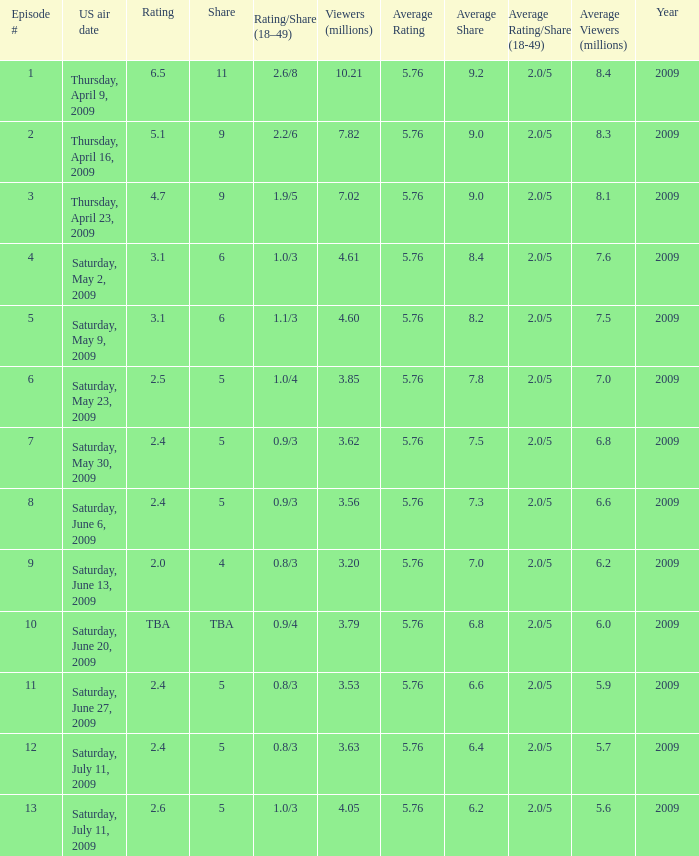What is the lowest numbered episode that had a rating/share of 0.9/4 and more than 3.79 million viewers? None. 